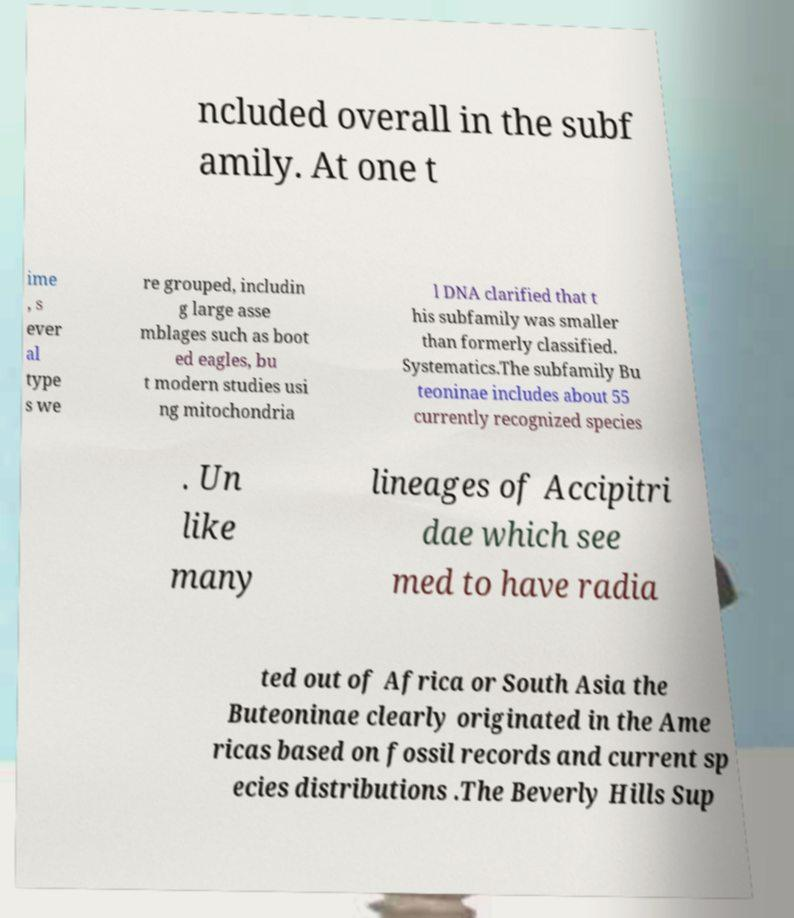Please identify and transcribe the text found in this image. ncluded overall in the subf amily. At one t ime , s ever al type s we re grouped, includin g large asse mblages such as boot ed eagles, bu t modern studies usi ng mitochondria l DNA clarified that t his subfamily was smaller than formerly classified. Systematics.The subfamily Bu teoninae includes about 55 currently recognized species . Un like many lineages of Accipitri dae which see med to have radia ted out of Africa or South Asia the Buteoninae clearly originated in the Ame ricas based on fossil records and current sp ecies distributions .The Beverly Hills Sup 